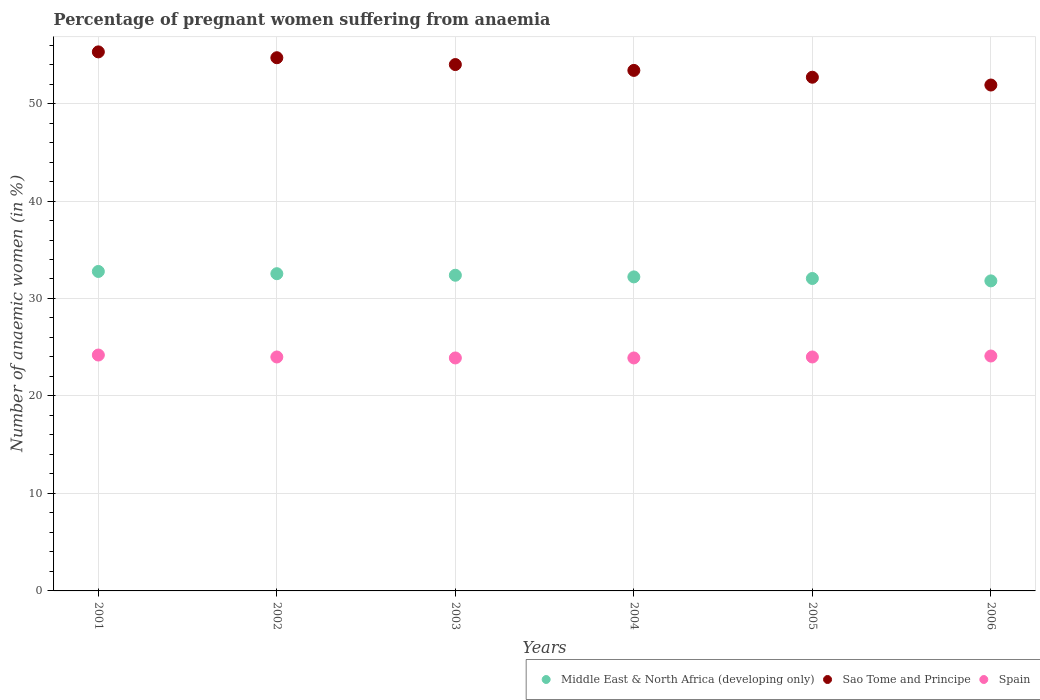How many different coloured dotlines are there?
Your answer should be very brief. 3. What is the number of anaemic women in Spain in 2003?
Provide a short and direct response. 23.9. Across all years, what is the maximum number of anaemic women in Spain?
Ensure brevity in your answer.  24.2. Across all years, what is the minimum number of anaemic women in Spain?
Ensure brevity in your answer.  23.9. In which year was the number of anaemic women in Sao Tome and Principe minimum?
Ensure brevity in your answer.  2006. What is the total number of anaemic women in Spain in the graph?
Offer a very short reply. 144.1. What is the difference between the number of anaemic women in Middle East & North Africa (developing only) in 2003 and that in 2005?
Provide a succinct answer. 0.33. What is the difference between the number of anaemic women in Sao Tome and Principe in 2002 and the number of anaemic women in Middle East & North Africa (developing only) in 2005?
Your answer should be very brief. 22.65. What is the average number of anaemic women in Spain per year?
Provide a succinct answer. 24.02. In the year 2003, what is the difference between the number of anaemic women in Sao Tome and Principe and number of anaemic women in Spain?
Offer a terse response. 30.1. In how many years, is the number of anaemic women in Sao Tome and Principe greater than 4 %?
Ensure brevity in your answer.  6. What is the ratio of the number of anaemic women in Sao Tome and Principe in 2005 to that in 2006?
Give a very brief answer. 1.02. Is the number of anaemic women in Sao Tome and Principe in 2001 less than that in 2003?
Offer a terse response. No. What is the difference between the highest and the second highest number of anaemic women in Spain?
Your answer should be compact. 0.1. What is the difference between the highest and the lowest number of anaemic women in Middle East & North Africa (developing only)?
Make the answer very short. 0.97. Is the sum of the number of anaemic women in Middle East & North Africa (developing only) in 2002 and 2004 greater than the maximum number of anaemic women in Spain across all years?
Your answer should be compact. Yes. Does the number of anaemic women in Middle East & North Africa (developing only) monotonically increase over the years?
Offer a terse response. No. Is the number of anaemic women in Sao Tome and Principe strictly less than the number of anaemic women in Middle East & North Africa (developing only) over the years?
Ensure brevity in your answer.  No. Does the graph contain any zero values?
Offer a very short reply. No. Does the graph contain grids?
Give a very brief answer. Yes. Where does the legend appear in the graph?
Offer a very short reply. Bottom right. What is the title of the graph?
Give a very brief answer. Percentage of pregnant women suffering from anaemia. Does "Thailand" appear as one of the legend labels in the graph?
Keep it short and to the point. No. What is the label or title of the Y-axis?
Your answer should be compact. Number of anaemic women (in %). What is the Number of anaemic women (in %) of Middle East & North Africa (developing only) in 2001?
Make the answer very short. 32.77. What is the Number of anaemic women (in %) in Sao Tome and Principe in 2001?
Give a very brief answer. 55.3. What is the Number of anaemic women (in %) of Spain in 2001?
Provide a short and direct response. 24.2. What is the Number of anaemic women (in %) in Middle East & North Africa (developing only) in 2002?
Give a very brief answer. 32.54. What is the Number of anaemic women (in %) in Sao Tome and Principe in 2002?
Your answer should be compact. 54.7. What is the Number of anaemic women (in %) of Middle East & North Africa (developing only) in 2003?
Ensure brevity in your answer.  32.39. What is the Number of anaemic women (in %) of Spain in 2003?
Ensure brevity in your answer.  23.9. What is the Number of anaemic women (in %) of Middle East & North Africa (developing only) in 2004?
Ensure brevity in your answer.  32.22. What is the Number of anaemic women (in %) of Sao Tome and Principe in 2004?
Make the answer very short. 53.4. What is the Number of anaemic women (in %) in Spain in 2004?
Your answer should be very brief. 23.9. What is the Number of anaemic women (in %) in Middle East & North Africa (developing only) in 2005?
Give a very brief answer. 32.05. What is the Number of anaemic women (in %) in Sao Tome and Principe in 2005?
Ensure brevity in your answer.  52.7. What is the Number of anaemic women (in %) in Middle East & North Africa (developing only) in 2006?
Keep it short and to the point. 31.81. What is the Number of anaemic women (in %) in Sao Tome and Principe in 2006?
Offer a terse response. 51.9. What is the Number of anaemic women (in %) in Spain in 2006?
Keep it short and to the point. 24.1. Across all years, what is the maximum Number of anaemic women (in %) of Middle East & North Africa (developing only)?
Give a very brief answer. 32.77. Across all years, what is the maximum Number of anaemic women (in %) in Sao Tome and Principe?
Your answer should be compact. 55.3. Across all years, what is the maximum Number of anaemic women (in %) in Spain?
Ensure brevity in your answer.  24.2. Across all years, what is the minimum Number of anaemic women (in %) in Middle East & North Africa (developing only)?
Give a very brief answer. 31.81. Across all years, what is the minimum Number of anaemic women (in %) in Sao Tome and Principe?
Offer a terse response. 51.9. Across all years, what is the minimum Number of anaemic women (in %) in Spain?
Keep it short and to the point. 23.9. What is the total Number of anaemic women (in %) of Middle East & North Africa (developing only) in the graph?
Your response must be concise. 193.78. What is the total Number of anaemic women (in %) of Sao Tome and Principe in the graph?
Keep it short and to the point. 322. What is the total Number of anaemic women (in %) of Spain in the graph?
Ensure brevity in your answer.  144.1. What is the difference between the Number of anaemic women (in %) of Middle East & North Africa (developing only) in 2001 and that in 2002?
Your answer should be very brief. 0.23. What is the difference between the Number of anaemic women (in %) in Sao Tome and Principe in 2001 and that in 2002?
Offer a terse response. 0.6. What is the difference between the Number of anaemic women (in %) of Middle East & North Africa (developing only) in 2001 and that in 2003?
Your answer should be very brief. 0.39. What is the difference between the Number of anaemic women (in %) of Middle East & North Africa (developing only) in 2001 and that in 2004?
Offer a very short reply. 0.56. What is the difference between the Number of anaemic women (in %) of Middle East & North Africa (developing only) in 2001 and that in 2005?
Give a very brief answer. 0.72. What is the difference between the Number of anaemic women (in %) in Sao Tome and Principe in 2001 and that in 2005?
Ensure brevity in your answer.  2.6. What is the difference between the Number of anaemic women (in %) of Spain in 2001 and that in 2005?
Provide a succinct answer. 0.2. What is the difference between the Number of anaemic women (in %) of Middle East & North Africa (developing only) in 2001 and that in 2006?
Give a very brief answer. 0.97. What is the difference between the Number of anaemic women (in %) in Spain in 2001 and that in 2006?
Provide a succinct answer. 0.1. What is the difference between the Number of anaemic women (in %) in Middle East & North Africa (developing only) in 2002 and that in 2003?
Ensure brevity in your answer.  0.16. What is the difference between the Number of anaemic women (in %) of Middle East & North Africa (developing only) in 2002 and that in 2004?
Your answer should be compact. 0.33. What is the difference between the Number of anaemic women (in %) of Sao Tome and Principe in 2002 and that in 2004?
Your answer should be very brief. 1.3. What is the difference between the Number of anaemic women (in %) in Middle East & North Africa (developing only) in 2002 and that in 2005?
Keep it short and to the point. 0.49. What is the difference between the Number of anaemic women (in %) in Middle East & North Africa (developing only) in 2002 and that in 2006?
Offer a terse response. 0.74. What is the difference between the Number of anaemic women (in %) of Spain in 2002 and that in 2006?
Provide a short and direct response. -0.1. What is the difference between the Number of anaemic women (in %) of Middle East & North Africa (developing only) in 2003 and that in 2004?
Offer a terse response. 0.17. What is the difference between the Number of anaemic women (in %) of Spain in 2003 and that in 2004?
Ensure brevity in your answer.  0. What is the difference between the Number of anaemic women (in %) of Middle East & North Africa (developing only) in 2003 and that in 2005?
Your answer should be very brief. 0.33. What is the difference between the Number of anaemic women (in %) of Middle East & North Africa (developing only) in 2003 and that in 2006?
Your answer should be compact. 0.58. What is the difference between the Number of anaemic women (in %) of Sao Tome and Principe in 2003 and that in 2006?
Give a very brief answer. 2.1. What is the difference between the Number of anaemic women (in %) of Spain in 2003 and that in 2006?
Offer a very short reply. -0.2. What is the difference between the Number of anaemic women (in %) of Middle East & North Africa (developing only) in 2004 and that in 2005?
Provide a short and direct response. 0.16. What is the difference between the Number of anaemic women (in %) in Middle East & North Africa (developing only) in 2004 and that in 2006?
Give a very brief answer. 0.41. What is the difference between the Number of anaemic women (in %) in Sao Tome and Principe in 2004 and that in 2006?
Provide a short and direct response. 1.5. What is the difference between the Number of anaemic women (in %) in Spain in 2004 and that in 2006?
Offer a terse response. -0.2. What is the difference between the Number of anaemic women (in %) of Middle East & North Africa (developing only) in 2005 and that in 2006?
Your response must be concise. 0.25. What is the difference between the Number of anaemic women (in %) in Spain in 2005 and that in 2006?
Provide a short and direct response. -0.1. What is the difference between the Number of anaemic women (in %) of Middle East & North Africa (developing only) in 2001 and the Number of anaemic women (in %) of Sao Tome and Principe in 2002?
Your answer should be very brief. -21.93. What is the difference between the Number of anaemic women (in %) in Middle East & North Africa (developing only) in 2001 and the Number of anaemic women (in %) in Spain in 2002?
Give a very brief answer. 8.77. What is the difference between the Number of anaemic women (in %) of Sao Tome and Principe in 2001 and the Number of anaemic women (in %) of Spain in 2002?
Your answer should be very brief. 31.3. What is the difference between the Number of anaemic women (in %) of Middle East & North Africa (developing only) in 2001 and the Number of anaemic women (in %) of Sao Tome and Principe in 2003?
Provide a short and direct response. -21.23. What is the difference between the Number of anaemic women (in %) in Middle East & North Africa (developing only) in 2001 and the Number of anaemic women (in %) in Spain in 2003?
Make the answer very short. 8.87. What is the difference between the Number of anaemic women (in %) in Sao Tome and Principe in 2001 and the Number of anaemic women (in %) in Spain in 2003?
Give a very brief answer. 31.4. What is the difference between the Number of anaemic women (in %) in Middle East & North Africa (developing only) in 2001 and the Number of anaemic women (in %) in Sao Tome and Principe in 2004?
Ensure brevity in your answer.  -20.63. What is the difference between the Number of anaemic women (in %) in Middle East & North Africa (developing only) in 2001 and the Number of anaemic women (in %) in Spain in 2004?
Keep it short and to the point. 8.87. What is the difference between the Number of anaemic women (in %) of Sao Tome and Principe in 2001 and the Number of anaemic women (in %) of Spain in 2004?
Keep it short and to the point. 31.4. What is the difference between the Number of anaemic women (in %) of Middle East & North Africa (developing only) in 2001 and the Number of anaemic women (in %) of Sao Tome and Principe in 2005?
Offer a terse response. -19.93. What is the difference between the Number of anaemic women (in %) in Middle East & North Africa (developing only) in 2001 and the Number of anaemic women (in %) in Spain in 2005?
Provide a short and direct response. 8.77. What is the difference between the Number of anaemic women (in %) in Sao Tome and Principe in 2001 and the Number of anaemic women (in %) in Spain in 2005?
Your answer should be compact. 31.3. What is the difference between the Number of anaemic women (in %) in Middle East & North Africa (developing only) in 2001 and the Number of anaemic women (in %) in Sao Tome and Principe in 2006?
Your answer should be very brief. -19.13. What is the difference between the Number of anaemic women (in %) in Middle East & North Africa (developing only) in 2001 and the Number of anaemic women (in %) in Spain in 2006?
Keep it short and to the point. 8.67. What is the difference between the Number of anaemic women (in %) of Sao Tome and Principe in 2001 and the Number of anaemic women (in %) of Spain in 2006?
Give a very brief answer. 31.2. What is the difference between the Number of anaemic women (in %) of Middle East & North Africa (developing only) in 2002 and the Number of anaemic women (in %) of Sao Tome and Principe in 2003?
Provide a succinct answer. -21.46. What is the difference between the Number of anaemic women (in %) in Middle East & North Africa (developing only) in 2002 and the Number of anaemic women (in %) in Spain in 2003?
Offer a terse response. 8.64. What is the difference between the Number of anaemic women (in %) in Sao Tome and Principe in 2002 and the Number of anaemic women (in %) in Spain in 2003?
Provide a short and direct response. 30.8. What is the difference between the Number of anaemic women (in %) of Middle East & North Africa (developing only) in 2002 and the Number of anaemic women (in %) of Sao Tome and Principe in 2004?
Ensure brevity in your answer.  -20.86. What is the difference between the Number of anaemic women (in %) in Middle East & North Africa (developing only) in 2002 and the Number of anaemic women (in %) in Spain in 2004?
Your answer should be very brief. 8.64. What is the difference between the Number of anaemic women (in %) in Sao Tome and Principe in 2002 and the Number of anaemic women (in %) in Spain in 2004?
Provide a short and direct response. 30.8. What is the difference between the Number of anaemic women (in %) of Middle East & North Africa (developing only) in 2002 and the Number of anaemic women (in %) of Sao Tome and Principe in 2005?
Provide a succinct answer. -20.16. What is the difference between the Number of anaemic women (in %) of Middle East & North Africa (developing only) in 2002 and the Number of anaemic women (in %) of Spain in 2005?
Offer a very short reply. 8.54. What is the difference between the Number of anaemic women (in %) of Sao Tome and Principe in 2002 and the Number of anaemic women (in %) of Spain in 2005?
Make the answer very short. 30.7. What is the difference between the Number of anaemic women (in %) in Middle East & North Africa (developing only) in 2002 and the Number of anaemic women (in %) in Sao Tome and Principe in 2006?
Provide a short and direct response. -19.36. What is the difference between the Number of anaemic women (in %) of Middle East & North Africa (developing only) in 2002 and the Number of anaemic women (in %) of Spain in 2006?
Offer a very short reply. 8.44. What is the difference between the Number of anaemic women (in %) of Sao Tome and Principe in 2002 and the Number of anaemic women (in %) of Spain in 2006?
Give a very brief answer. 30.6. What is the difference between the Number of anaemic women (in %) of Middle East & North Africa (developing only) in 2003 and the Number of anaemic women (in %) of Sao Tome and Principe in 2004?
Make the answer very short. -21.01. What is the difference between the Number of anaemic women (in %) of Middle East & North Africa (developing only) in 2003 and the Number of anaemic women (in %) of Spain in 2004?
Your response must be concise. 8.49. What is the difference between the Number of anaemic women (in %) of Sao Tome and Principe in 2003 and the Number of anaemic women (in %) of Spain in 2004?
Your answer should be very brief. 30.1. What is the difference between the Number of anaemic women (in %) of Middle East & North Africa (developing only) in 2003 and the Number of anaemic women (in %) of Sao Tome and Principe in 2005?
Offer a very short reply. -20.31. What is the difference between the Number of anaemic women (in %) in Middle East & North Africa (developing only) in 2003 and the Number of anaemic women (in %) in Spain in 2005?
Provide a succinct answer. 8.39. What is the difference between the Number of anaemic women (in %) in Sao Tome and Principe in 2003 and the Number of anaemic women (in %) in Spain in 2005?
Offer a very short reply. 30. What is the difference between the Number of anaemic women (in %) in Middle East & North Africa (developing only) in 2003 and the Number of anaemic women (in %) in Sao Tome and Principe in 2006?
Your response must be concise. -19.51. What is the difference between the Number of anaemic women (in %) in Middle East & North Africa (developing only) in 2003 and the Number of anaemic women (in %) in Spain in 2006?
Ensure brevity in your answer.  8.29. What is the difference between the Number of anaemic women (in %) of Sao Tome and Principe in 2003 and the Number of anaemic women (in %) of Spain in 2006?
Give a very brief answer. 29.9. What is the difference between the Number of anaemic women (in %) in Middle East & North Africa (developing only) in 2004 and the Number of anaemic women (in %) in Sao Tome and Principe in 2005?
Offer a very short reply. -20.48. What is the difference between the Number of anaemic women (in %) of Middle East & North Africa (developing only) in 2004 and the Number of anaemic women (in %) of Spain in 2005?
Offer a terse response. 8.22. What is the difference between the Number of anaemic women (in %) in Sao Tome and Principe in 2004 and the Number of anaemic women (in %) in Spain in 2005?
Offer a very short reply. 29.4. What is the difference between the Number of anaemic women (in %) in Middle East & North Africa (developing only) in 2004 and the Number of anaemic women (in %) in Sao Tome and Principe in 2006?
Give a very brief answer. -19.68. What is the difference between the Number of anaemic women (in %) of Middle East & North Africa (developing only) in 2004 and the Number of anaemic women (in %) of Spain in 2006?
Offer a terse response. 8.12. What is the difference between the Number of anaemic women (in %) in Sao Tome and Principe in 2004 and the Number of anaemic women (in %) in Spain in 2006?
Ensure brevity in your answer.  29.3. What is the difference between the Number of anaemic women (in %) in Middle East & North Africa (developing only) in 2005 and the Number of anaemic women (in %) in Sao Tome and Principe in 2006?
Your answer should be very brief. -19.85. What is the difference between the Number of anaemic women (in %) in Middle East & North Africa (developing only) in 2005 and the Number of anaemic women (in %) in Spain in 2006?
Ensure brevity in your answer.  7.95. What is the difference between the Number of anaemic women (in %) of Sao Tome and Principe in 2005 and the Number of anaemic women (in %) of Spain in 2006?
Ensure brevity in your answer.  28.6. What is the average Number of anaemic women (in %) in Middle East & North Africa (developing only) per year?
Provide a short and direct response. 32.3. What is the average Number of anaemic women (in %) of Sao Tome and Principe per year?
Keep it short and to the point. 53.67. What is the average Number of anaemic women (in %) in Spain per year?
Offer a terse response. 24.02. In the year 2001, what is the difference between the Number of anaemic women (in %) in Middle East & North Africa (developing only) and Number of anaemic women (in %) in Sao Tome and Principe?
Your answer should be compact. -22.53. In the year 2001, what is the difference between the Number of anaemic women (in %) in Middle East & North Africa (developing only) and Number of anaemic women (in %) in Spain?
Make the answer very short. 8.57. In the year 2001, what is the difference between the Number of anaemic women (in %) of Sao Tome and Principe and Number of anaemic women (in %) of Spain?
Offer a very short reply. 31.1. In the year 2002, what is the difference between the Number of anaemic women (in %) of Middle East & North Africa (developing only) and Number of anaemic women (in %) of Sao Tome and Principe?
Offer a terse response. -22.16. In the year 2002, what is the difference between the Number of anaemic women (in %) of Middle East & North Africa (developing only) and Number of anaemic women (in %) of Spain?
Provide a succinct answer. 8.54. In the year 2002, what is the difference between the Number of anaemic women (in %) of Sao Tome and Principe and Number of anaemic women (in %) of Spain?
Ensure brevity in your answer.  30.7. In the year 2003, what is the difference between the Number of anaemic women (in %) in Middle East & North Africa (developing only) and Number of anaemic women (in %) in Sao Tome and Principe?
Offer a terse response. -21.61. In the year 2003, what is the difference between the Number of anaemic women (in %) in Middle East & North Africa (developing only) and Number of anaemic women (in %) in Spain?
Keep it short and to the point. 8.49. In the year 2003, what is the difference between the Number of anaemic women (in %) in Sao Tome and Principe and Number of anaemic women (in %) in Spain?
Make the answer very short. 30.1. In the year 2004, what is the difference between the Number of anaemic women (in %) of Middle East & North Africa (developing only) and Number of anaemic women (in %) of Sao Tome and Principe?
Make the answer very short. -21.18. In the year 2004, what is the difference between the Number of anaemic women (in %) of Middle East & North Africa (developing only) and Number of anaemic women (in %) of Spain?
Provide a succinct answer. 8.32. In the year 2004, what is the difference between the Number of anaemic women (in %) of Sao Tome and Principe and Number of anaemic women (in %) of Spain?
Provide a short and direct response. 29.5. In the year 2005, what is the difference between the Number of anaemic women (in %) in Middle East & North Africa (developing only) and Number of anaemic women (in %) in Sao Tome and Principe?
Provide a short and direct response. -20.65. In the year 2005, what is the difference between the Number of anaemic women (in %) in Middle East & North Africa (developing only) and Number of anaemic women (in %) in Spain?
Ensure brevity in your answer.  8.05. In the year 2005, what is the difference between the Number of anaemic women (in %) of Sao Tome and Principe and Number of anaemic women (in %) of Spain?
Ensure brevity in your answer.  28.7. In the year 2006, what is the difference between the Number of anaemic women (in %) of Middle East & North Africa (developing only) and Number of anaemic women (in %) of Sao Tome and Principe?
Make the answer very short. -20.09. In the year 2006, what is the difference between the Number of anaemic women (in %) of Middle East & North Africa (developing only) and Number of anaemic women (in %) of Spain?
Provide a succinct answer. 7.71. In the year 2006, what is the difference between the Number of anaemic women (in %) in Sao Tome and Principe and Number of anaemic women (in %) in Spain?
Your answer should be compact. 27.8. What is the ratio of the Number of anaemic women (in %) of Middle East & North Africa (developing only) in 2001 to that in 2002?
Provide a short and direct response. 1.01. What is the ratio of the Number of anaemic women (in %) in Sao Tome and Principe in 2001 to that in 2002?
Provide a short and direct response. 1.01. What is the ratio of the Number of anaemic women (in %) of Spain in 2001 to that in 2002?
Give a very brief answer. 1.01. What is the ratio of the Number of anaemic women (in %) in Middle East & North Africa (developing only) in 2001 to that in 2003?
Provide a succinct answer. 1.01. What is the ratio of the Number of anaemic women (in %) in Sao Tome and Principe in 2001 to that in 2003?
Your response must be concise. 1.02. What is the ratio of the Number of anaemic women (in %) in Spain in 2001 to that in 2003?
Your response must be concise. 1.01. What is the ratio of the Number of anaemic women (in %) of Middle East & North Africa (developing only) in 2001 to that in 2004?
Keep it short and to the point. 1.02. What is the ratio of the Number of anaemic women (in %) of Sao Tome and Principe in 2001 to that in 2004?
Provide a succinct answer. 1.04. What is the ratio of the Number of anaemic women (in %) of Spain in 2001 to that in 2004?
Your response must be concise. 1.01. What is the ratio of the Number of anaemic women (in %) in Middle East & North Africa (developing only) in 2001 to that in 2005?
Make the answer very short. 1.02. What is the ratio of the Number of anaemic women (in %) of Sao Tome and Principe in 2001 to that in 2005?
Keep it short and to the point. 1.05. What is the ratio of the Number of anaemic women (in %) in Spain in 2001 to that in 2005?
Your answer should be compact. 1.01. What is the ratio of the Number of anaemic women (in %) in Middle East & North Africa (developing only) in 2001 to that in 2006?
Your response must be concise. 1.03. What is the ratio of the Number of anaemic women (in %) of Sao Tome and Principe in 2001 to that in 2006?
Your response must be concise. 1.07. What is the ratio of the Number of anaemic women (in %) of Spain in 2001 to that in 2006?
Make the answer very short. 1. What is the ratio of the Number of anaemic women (in %) in Middle East & North Africa (developing only) in 2002 to that in 2004?
Offer a very short reply. 1.01. What is the ratio of the Number of anaemic women (in %) in Sao Tome and Principe in 2002 to that in 2004?
Your answer should be compact. 1.02. What is the ratio of the Number of anaemic women (in %) in Middle East & North Africa (developing only) in 2002 to that in 2005?
Your answer should be compact. 1.02. What is the ratio of the Number of anaemic women (in %) of Sao Tome and Principe in 2002 to that in 2005?
Make the answer very short. 1.04. What is the ratio of the Number of anaemic women (in %) in Middle East & North Africa (developing only) in 2002 to that in 2006?
Your answer should be compact. 1.02. What is the ratio of the Number of anaemic women (in %) in Sao Tome and Principe in 2002 to that in 2006?
Provide a short and direct response. 1.05. What is the ratio of the Number of anaemic women (in %) of Spain in 2002 to that in 2006?
Offer a terse response. 1. What is the ratio of the Number of anaemic women (in %) of Middle East & North Africa (developing only) in 2003 to that in 2004?
Ensure brevity in your answer.  1.01. What is the ratio of the Number of anaemic women (in %) in Sao Tome and Principe in 2003 to that in 2004?
Keep it short and to the point. 1.01. What is the ratio of the Number of anaemic women (in %) of Middle East & North Africa (developing only) in 2003 to that in 2005?
Your answer should be very brief. 1.01. What is the ratio of the Number of anaemic women (in %) in Sao Tome and Principe in 2003 to that in 2005?
Make the answer very short. 1.02. What is the ratio of the Number of anaemic women (in %) of Spain in 2003 to that in 2005?
Give a very brief answer. 1. What is the ratio of the Number of anaemic women (in %) in Middle East & North Africa (developing only) in 2003 to that in 2006?
Provide a short and direct response. 1.02. What is the ratio of the Number of anaemic women (in %) of Sao Tome and Principe in 2003 to that in 2006?
Provide a short and direct response. 1.04. What is the ratio of the Number of anaemic women (in %) of Spain in 2003 to that in 2006?
Give a very brief answer. 0.99. What is the ratio of the Number of anaemic women (in %) in Middle East & North Africa (developing only) in 2004 to that in 2005?
Give a very brief answer. 1.01. What is the ratio of the Number of anaemic women (in %) in Sao Tome and Principe in 2004 to that in 2005?
Ensure brevity in your answer.  1.01. What is the ratio of the Number of anaemic women (in %) of Middle East & North Africa (developing only) in 2004 to that in 2006?
Make the answer very short. 1.01. What is the ratio of the Number of anaemic women (in %) of Sao Tome and Principe in 2004 to that in 2006?
Offer a terse response. 1.03. What is the ratio of the Number of anaemic women (in %) of Middle East & North Africa (developing only) in 2005 to that in 2006?
Your answer should be compact. 1.01. What is the ratio of the Number of anaemic women (in %) in Sao Tome and Principe in 2005 to that in 2006?
Ensure brevity in your answer.  1.02. What is the difference between the highest and the second highest Number of anaemic women (in %) in Middle East & North Africa (developing only)?
Your response must be concise. 0.23. What is the difference between the highest and the second highest Number of anaemic women (in %) of Sao Tome and Principe?
Your answer should be very brief. 0.6. What is the difference between the highest and the lowest Number of anaemic women (in %) of Spain?
Your answer should be very brief. 0.3. 